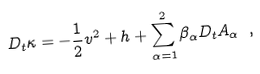Convert formula to latex. <formula><loc_0><loc_0><loc_500><loc_500>D _ { t } \kappa = - \frac { 1 } { 2 } v ^ { 2 } + h + \sum _ { \alpha = 1 } ^ { 2 } \beta _ { \alpha } D _ { t } A _ { \alpha } \ ,</formula> 